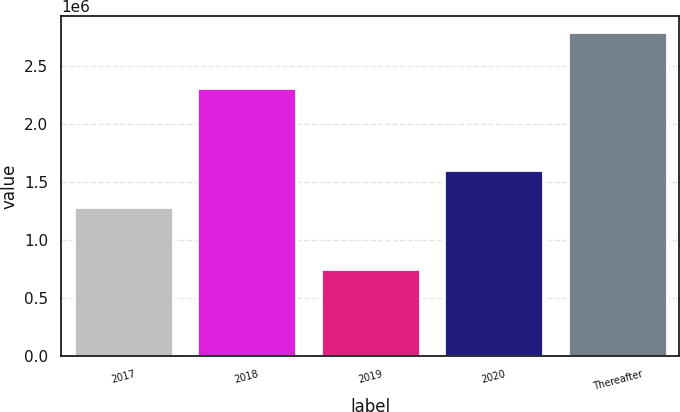Convert chart to OTSL. <chart><loc_0><loc_0><loc_500><loc_500><bar_chart><fcel>2017<fcel>2018<fcel>2019<fcel>2020<fcel>Thereafter<nl><fcel>1.28574e+06<fcel>2.30995e+06<fcel>754496<fcel>1.60819e+06<fcel>2.79615e+06<nl></chart> 